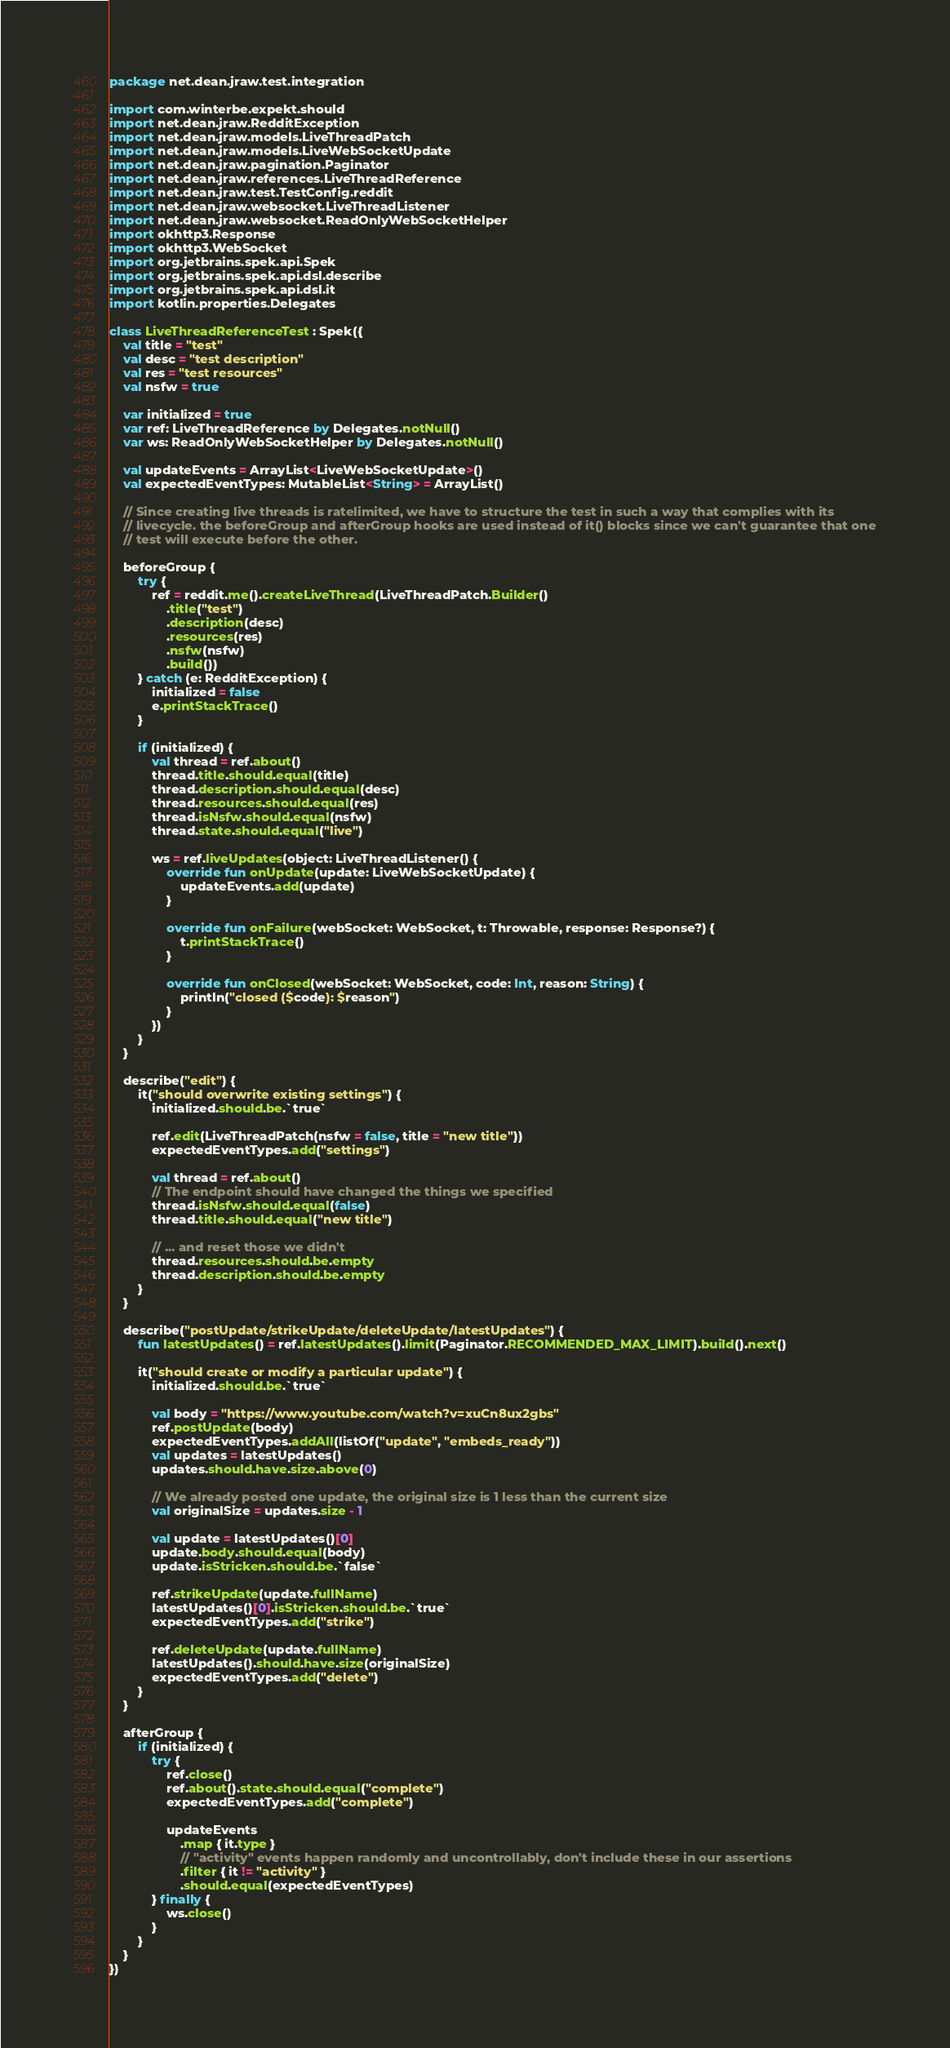<code> <loc_0><loc_0><loc_500><loc_500><_Kotlin_>package net.dean.jraw.test.integration

import com.winterbe.expekt.should
import net.dean.jraw.RedditException
import net.dean.jraw.models.LiveThreadPatch
import net.dean.jraw.models.LiveWebSocketUpdate
import net.dean.jraw.pagination.Paginator
import net.dean.jraw.references.LiveThreadReference
import net.dean.jraw.test.TestConfig.reddit
import net.dean.jraw.websocket.LiveThreadListener
import net.dean.jraw.websocket.ReadOnlyWebSocketHelper
import okhttp3.Response
import okhttp3.WebSocket
import org.jetbrains.spek.api.Spek
import org.jetbrains.spek.api.dsl.describe
import org.jetbrains.spek.api.dsl.it
import kotlin.properties.Delegates

class LiveThreadReferenceTest : Spek({
    val title = "test"
    val desc = "test description"
    val res = "test resources"
    val nsfw = true

    var initialized = true
    var ref: LiveThreadReference by Delegates.notNull()
    var ws: ReadOnlyWebSocketHelper by Delegates.notNull()

    val updateEvents = ArrayList<LiveWebSocketUpdate>()
    val expectedEventTypes: MutableList<String> = ArrayList()

    // Since creating live threads is ratelimited, we have to structure the test in such a way that complies with its
    // livecycle. the beforeGroup and afterGroup hooks are used instead of it() blocks since we can't guarantee that one
    // test will execute before the other.

    beforeGroup {
        try {
            ref = reddit.me().createLiveThread(LiveThreadPatch.Builder()
                .title("test")
                .description(desc)
                .resources(res)
                .nsfw(nsfw)
                .build())
        } catch (e: RedditException) {
            initialized = false
            e.printStackTrace()
        }

        if (initialized) {
            val thread = ref.about()
            thread.title.should.equal(title)
            thread.description.should.equal(desc)
            thread.resources.should.equal(res)
            thread.isNsfw.should.equal(nsfw)
            thread.state.should.equal("live")

            ws = ref.liveUpdates(object: LiveThreadListener() {
                override fun onUpdate(update: LiveWebSocketUpdate) {
                    updateEvents.add(update)
                }

                override fun onFailure(webSocket: WebSocket, t: Throwable, response: Response?) {
                    t.printStackTrace()
                }

                override fun onClosed(webSocket: WebSocket, code: Int, reason: String) {
                    println("closed ($code): $reason")
                }
            })
        }
    }

    describe("edit") {
        it("should overwrite existing settings") {
            initialized.should.be.`true`

            ref.edit(LiveThreadPatch(nsfw = false, title = "new title"))
            expectedEventTypes.add("settings")

            val thread = ref.about()
            // The endpoint should have changed the things we specified
            thread.isNsfw.should.equal(false)
            thread.title.should.equal("new title")

            // ... and reset those we didn't
            thread.resources.should.be.empty
            thread.description.should.be.empty
        }
    }

    describe("postUpdate/strikeUpdate/deleteUpdate/latestUpdates") {
        fun latestUpdates() = ref.latestUpdates().limit(Paginator.RECOMMENDED_MAX_LIMIT).build().next()

        it("should create or modify a particular update") {
            initialized.should.be.`true`

            val body = "https://www.youtube.com/watch?v=xuCn8ux2gbs"
            ref.postUpdate(body)
            expectedEventTypes.addAll(listOf("update", "embeds_ready"))
            val updates = latestUpdates()
            updates.should.have.size.above(0)

            // We already posted one update, the original size is 1 less than the current size
            val originalSize = updates.size - 1

            val update = latestUpdates()[0]
            update.body.should.equal(body)
            update.isStricken.should.be.`false`

            ref.strikeUpdate(update.fullName)
            latestUpdates()[0].isStricken.should.be.`true`
            expectedEventTypes.add("strike")

            ref.deleteUpdate(update.fullName)
            latestUpdates().should.have.size(originalSize)
            expectedEventTypes.add("delete")
        }
    }

    afterGroup {
        if (initialized) {
            try {
                ref.close()
                ref.about().state.should.equal("complete")
                expectedEventTypes.add("complete")

                updateEvents
                    .map { it.type }
                    // "activity" events happen randomly and uncontrollably, don't include these in our assertions
                    .filter { it != "activity" }
                    .should.equal(expectedEventTypes)
            } finally {
                ws.close()
            }
        }
    }
})
</code> 